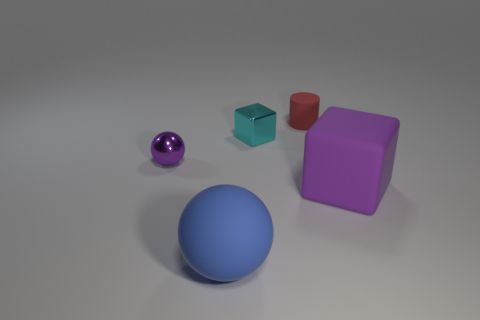Is the material of the blue thing the same as the purple sphere?
Your answer should be compact. No. Are there any other things that have the same material as the red object?
Ensure brevity in your answer.  Yes. Are there more tiny cyan shiny blocks that are in front of the tiny cyan block than small metallic balls?
Offer a very short reply. No. Do the metallic sphere and the small matte cylinder have the same color?
Offer a very short reply. No. What number of big purple things have the same shape as the tiny cyan shiny thing?
Give a very brief answer. 1. There is a purple object that is made of the same material as the red cylinder; what is its size?
Provide a succinct answer. Large. What is the color of the thing that is behind the rubber ball and in front of the purple metallic ball?
Offer a very short reply. Purple. What number of cyan metallic things have the same size as the blue object?
Keep it short and to the point. 0. What size is the thing that is the same color as the small metal ball?
Provide a succinct answer. Large. There is a rubber object that is both to the left of the large purple block and behind the blue matte ball; what is its size?
Provide a succinct answer. Small. 